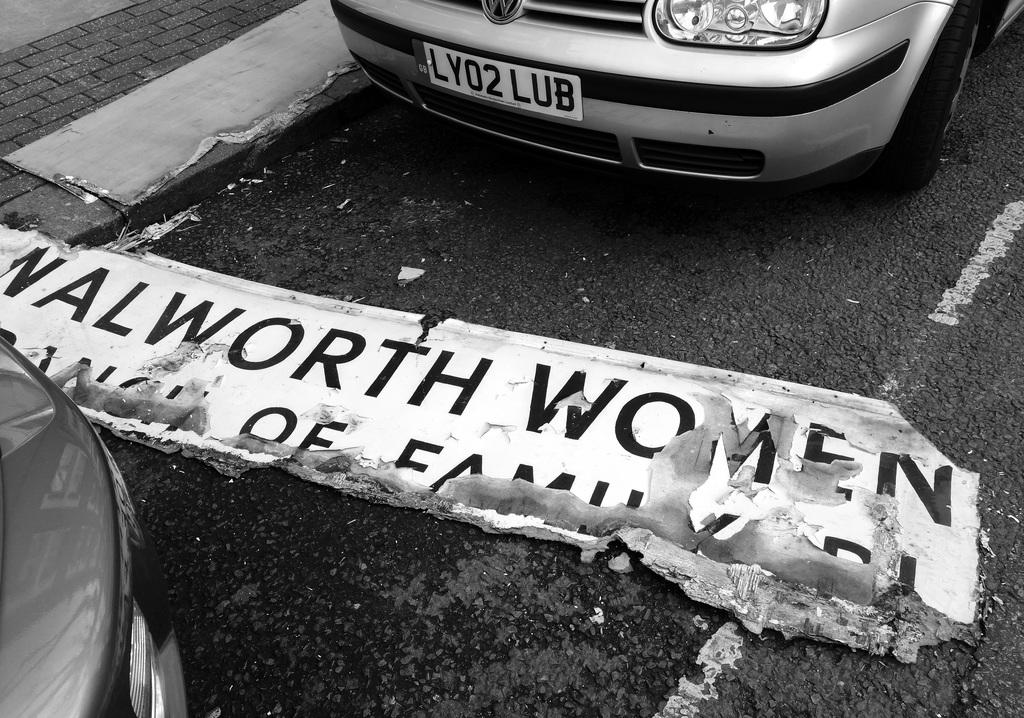<image>
Describe the image concisely. Sign in front of a car for walworth woman on the roaed 